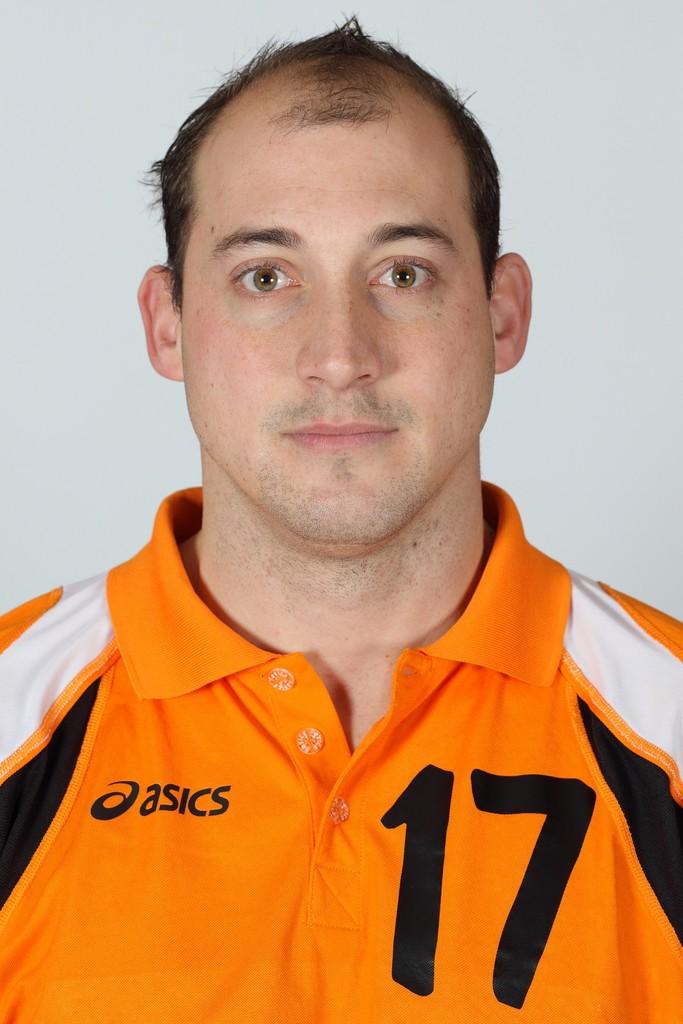Which clothing brand is this jersey made by?
Give a very brief answer. Asics. What number is on his shirt?
Your answer should be very brief. 17. 